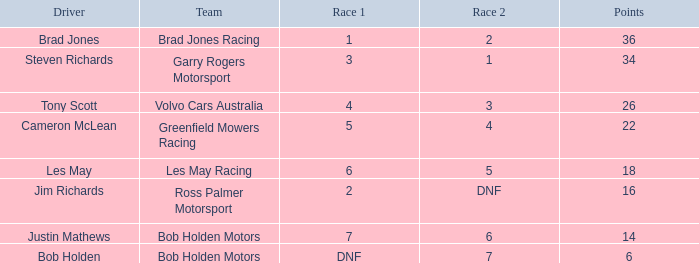Which squad achieved 4 in race 1? Volvo Cars Australia. Write the full table. {'header': ['Driver', 'Team', 'Race 1', 'Race 2', 'Points'], 'rows': [['Brad Jones', 'Brad Jones Racing', '1', '2', '36'], ['Steven Richards', 'Garry Rogers Motorsport', '3', '1', '34'], ['Tony Scott', 'Volvo Cars Australia', '4', '3', '26'], ['Cameron McLean', 'Greenfield Mowers Racing', '5', '4', '22'], ['Les May', 'Les May Racing', '6', '5', '18'], ['Jim Richards', 'Ross Palmer Motorsport', '2', 'DNF', '16'], ['Justin Mathews', 'Bob Holden Motors', '7', '6', '14'], ['Bob Holden', 'Bob Holden Motors', 'DNF', '7', '6']]} 